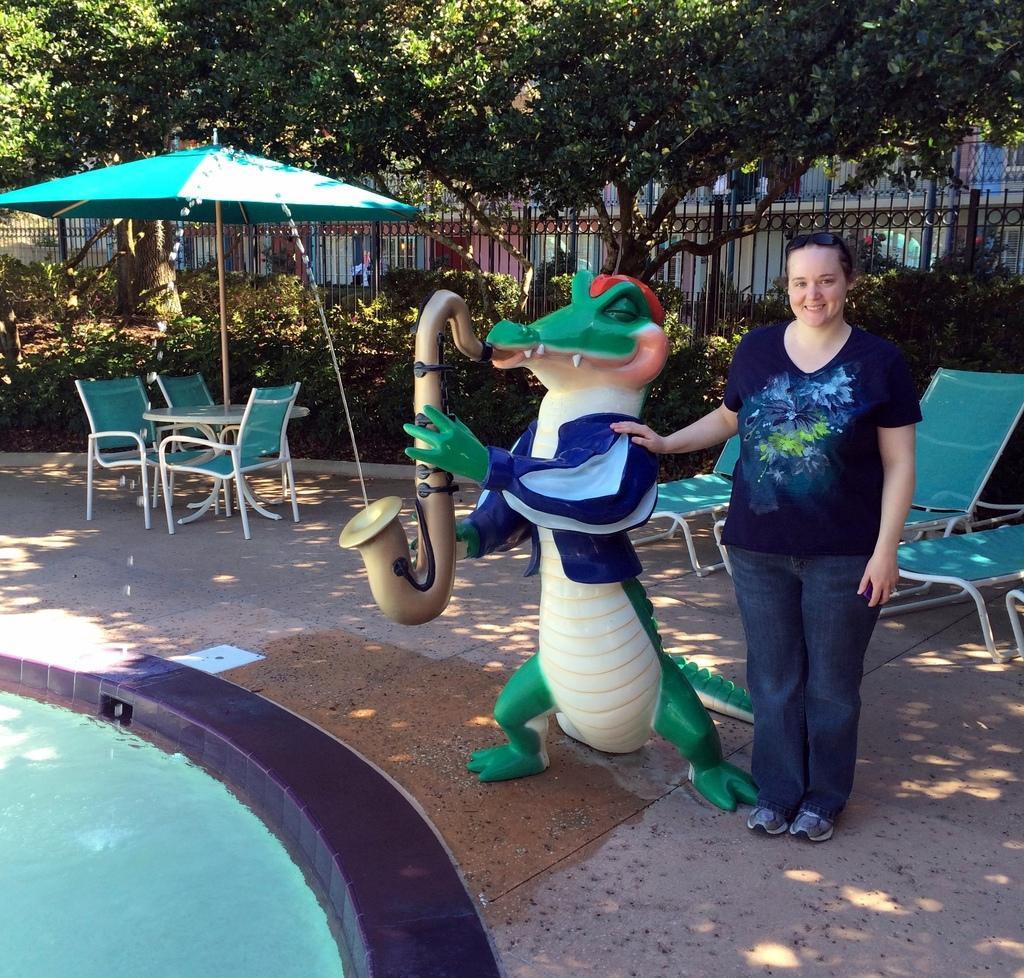How would you summarize this image in a sentence or two? There is a woman standing on the floor. She is smiling. This is toy. On the background we can see some chairs and this is umbrella. There is a fence and these are the trees. And this is swimming pool. 